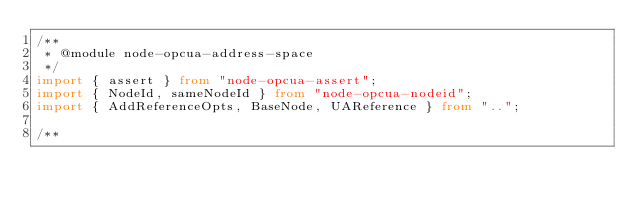Convert code to text. <code><loc_0><loc_0><loc_500><loc_500><_TypeScript_>/**
 * @module node-opcua-address-space
 */
import { assert } from "node-opcua-assert";
import { NodeId, sameNodeId } from "node-opcua-nodeid";
import { AddReferenceOpts, BaseNode, UAReference } from "..";

/**</code> 